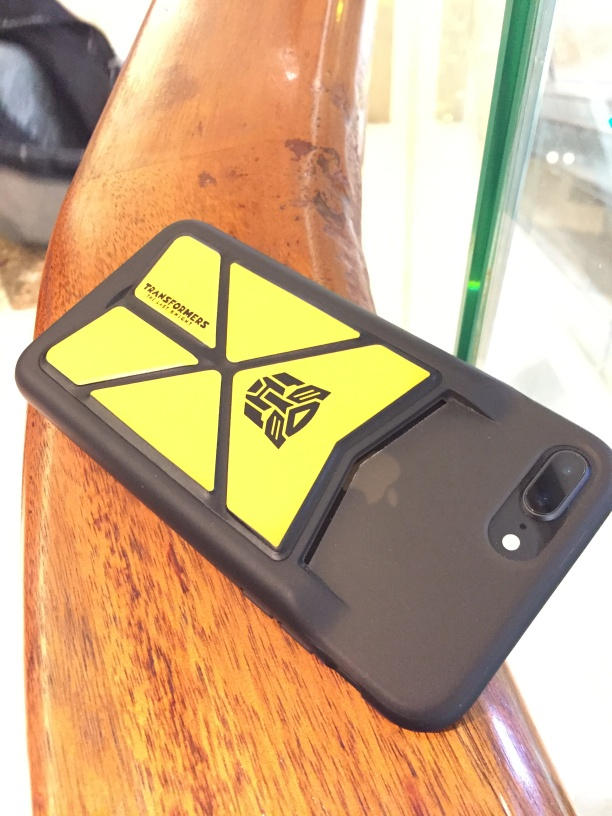In what setting is the phone placed, and does this offer any hints about the owner? The smartphone is resting on a polished wooden surface, which may suggest it's inside an establishment, possibly a home or a café. The casual placement might indicate the owner's comfort with the environment, suggesting it's a familiar and secure setting for them. 